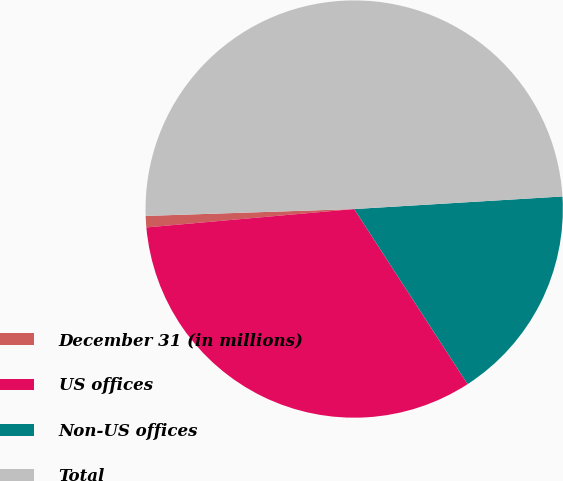Convert chart to OTSL. <chart><loc_0><loc_0><loc_500><loc_500><pie_chart><fcel>December 31 (in millions)<fcel>US offices<fcel>Non-US offices<fcel>Total<nl><fcel>0.88%<fcel>32.74%<fcel>16.81%<fcel>49.56%<nl></chart> 